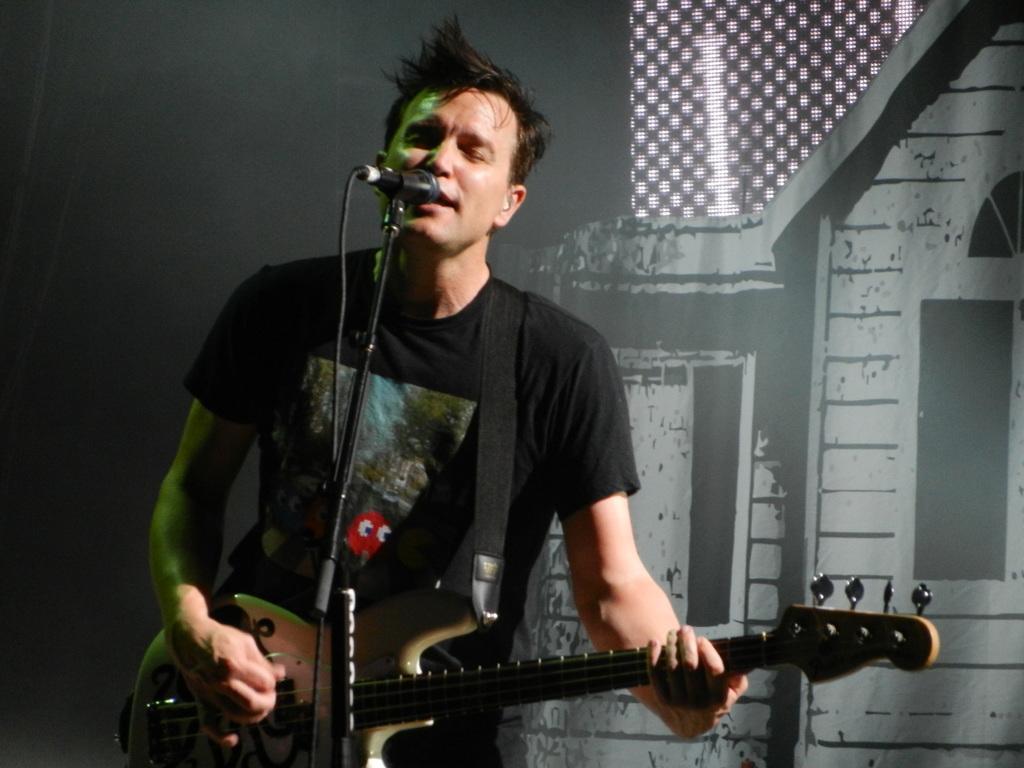Please provide a concise description of this image. In the image in the center we can see one person standing and playing guitar. In front of him,there is a microphone. In the background there is a curtain. 